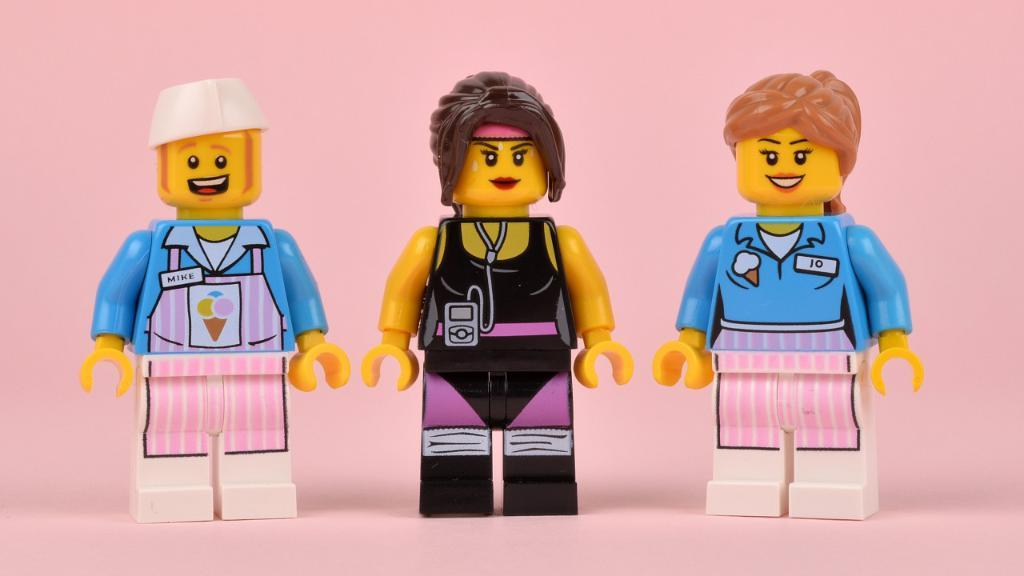How many Lego toys are visible in the image? There are three Lego toys in the image. What are the Lego toys placed on? The Lego toys are on an object. What is the texture of the chickens in the image? There are no chickens present in the image, so we cannot determine their texture. 